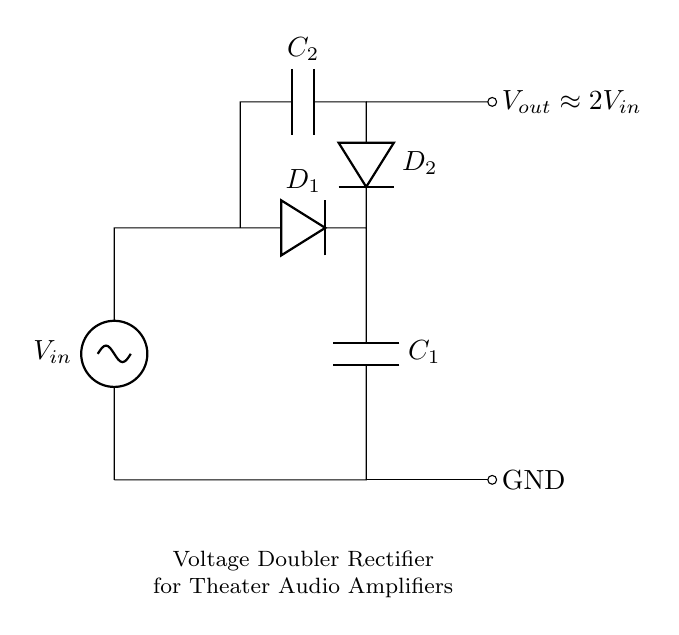What is the input voltage labeled in the circuit? The circuit diagram shows the input voltage as \(V_{in}\), which is a general representation of the input voltage to the rectifier from any source.
Answer: \(V_{in}\) How many capacitors are in the circuit? The circuit has two capacitors, \(C_1\) and \(C_2\), which are represented on the diagram to store charge and help boost the voltage output.
Answer: 2 What is the output voltage approximately equal to? The output voltage \(V_{out}\) is indicated to be approximately double the input voltage, as shown by the label near the output node.
Answer: \(2V_{in}\) What type of components are \(D_1\) and \(D_2\)? \(D_1\) and \(D_2\) are diodes, which are essential components in the rectifier circuit allowing current to flow in one direction and facilitating voltage doubling.
Answer: Diodes What is the purpose of the capacitors in this circuit? The capacitors \(C_1\) and \(C_2\) are used to store electrical energy and help smooth out the output voltage, thereby enhancing the performance of audio amplifiers.
Answer: Energy storage Why does the output voltage double? The design of the voltage doubler circuit, which uses two diodes and two capacitors, allows the circuit to generate an output voltage that is nearly double the input voltage by charging the capacitors in different phases of the AC cycle.
Answer: Circuit design 